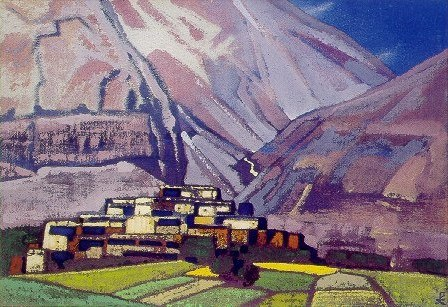Explain the visual content of the image in great detail. The image offers a captivating scene in an impressionistic style, where a picturesque village is the centerpiece. The buildings, quaint and closely packed, are painted with crisp white walls and vibrant orange roofs, providing a sharp contrast to the natural surroundings. These homes are nestled in a verdant valley, painted with a mix of vivid greens and subtle hints of yellow, suggesting fertile lands possibly used for agriculture. Rising majestically behind the village are towering mountains, depicted in broad strokes of blue and purple, suggesting both their ruggedness and the shadows cast by overhead clouds. This painting not only captures the physical beauty of the landscape but also evokes a sense of serene isolation, possibly hinting at the tranquility or the hard-to-reach nature of the village. The brushwork is apparent, adding texture and a dynamic quality to the scene, making the landscape seem alive with color and movement. 